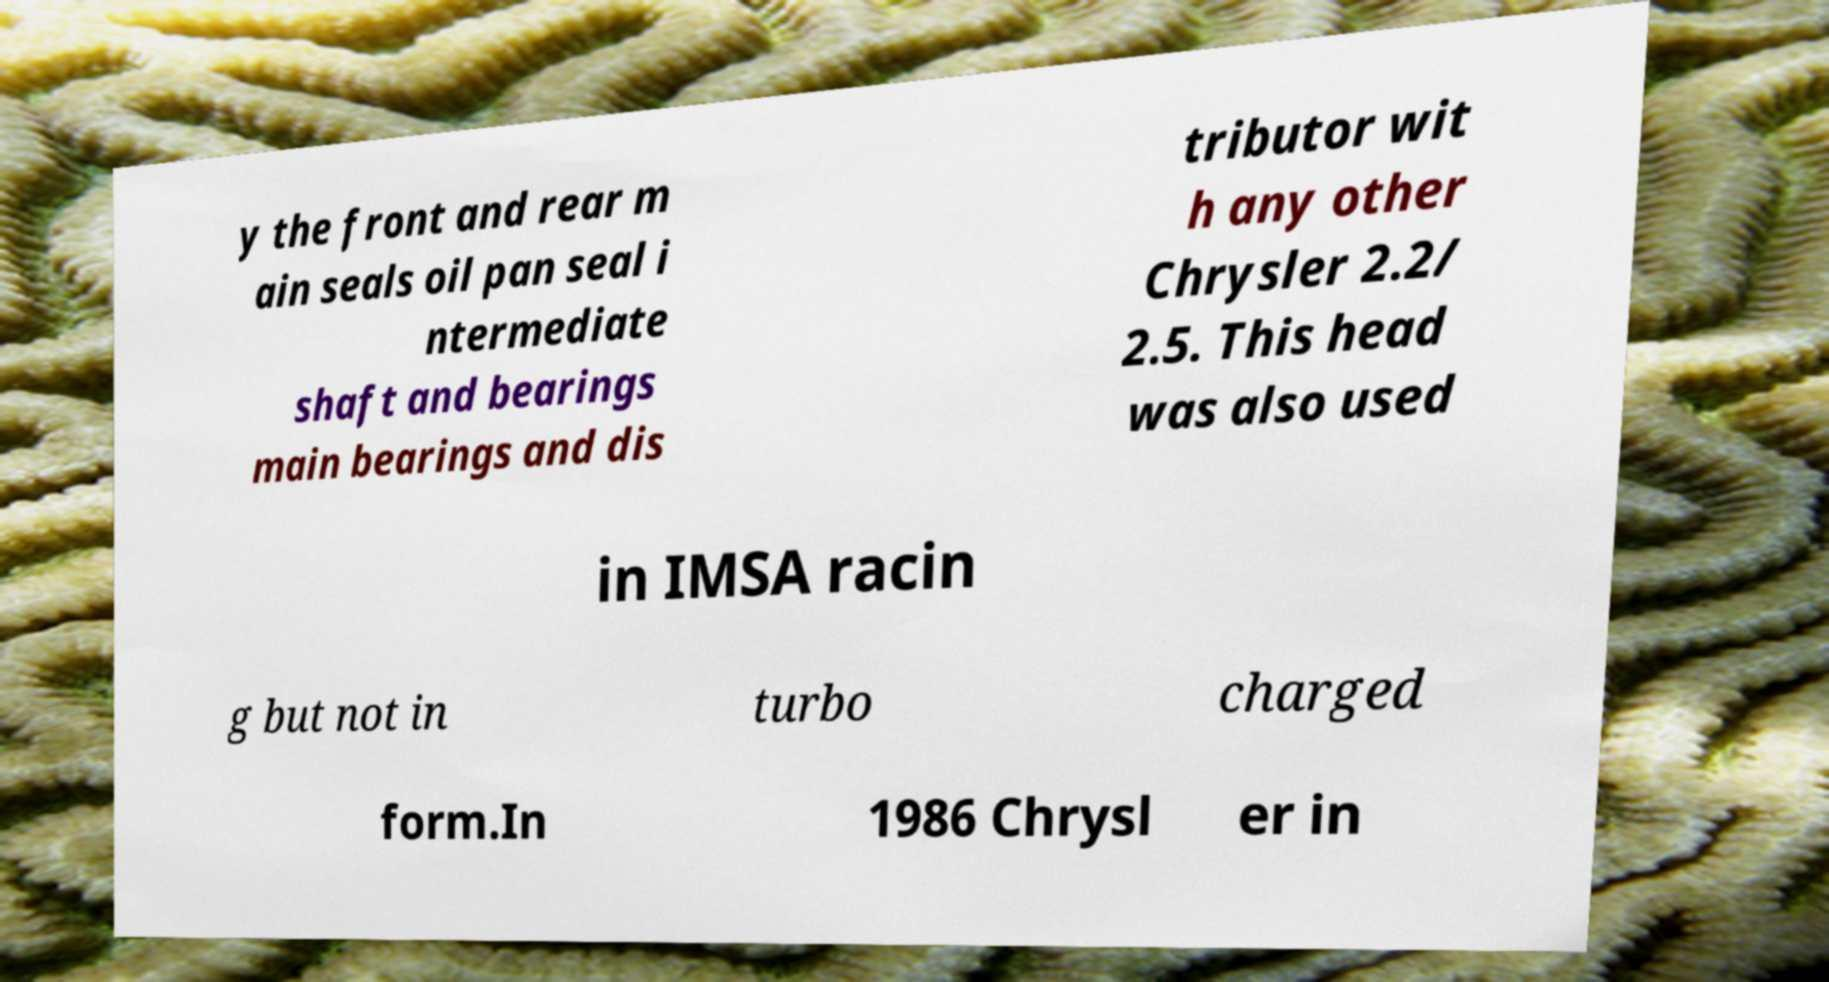There's text embedded in this image that I need extracted. Can you transcribe it verbatim? y the front and rear m ain seals oil pan seal i ntermediate shaft and bearings main bearings and dis tributor wit h any other Chrysler 2.2/ 2.5. This head was also used in IMSA racin g but not in turbo charged form.In 1986 Chrysl er in 